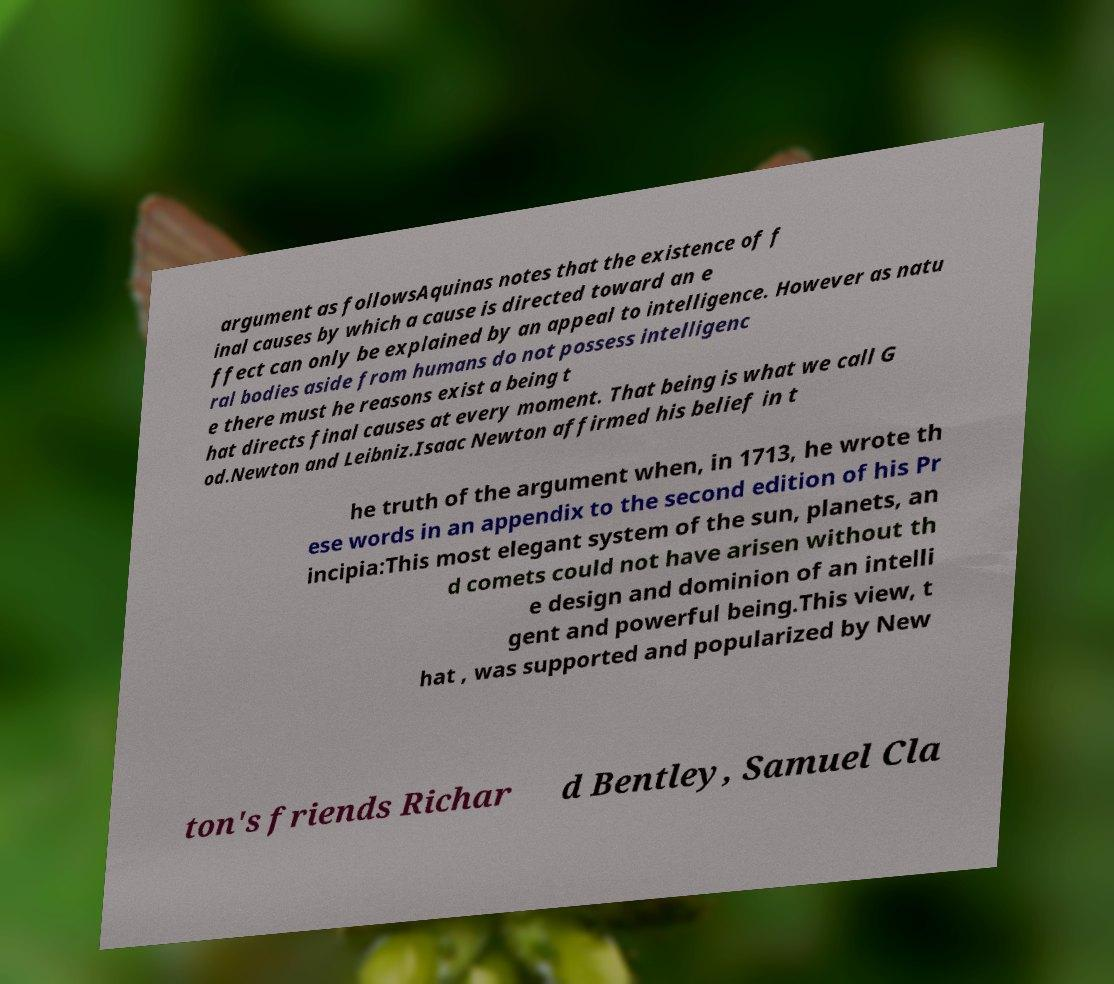Could you assist in decoding the text presented in this image and type it out clearly? argument as followsAquinas notes that the existence of f inal causes by which a cause is directed toward an e ffect can only be explained by an appeal to intelligence. However as natu ral bodies aside from humans do not possess intelligenc e there must he reasons exist a being t hat directs final causes at every moment. That being is what we call G od.Newton and Leibniz.Isaac Newton affirmed his belief in t he truth of the argument when, in 1713, he wrote th ese words in an appendix to the second edition of his Pr incipia:This most elegant system of the sun, planets, an d comets could not have arisen without th e design and dominion of an intelli gent and powerful being.This view, t hat , was supported and popularized by New ton's friends Richar d Bentley, Samuel Cla 